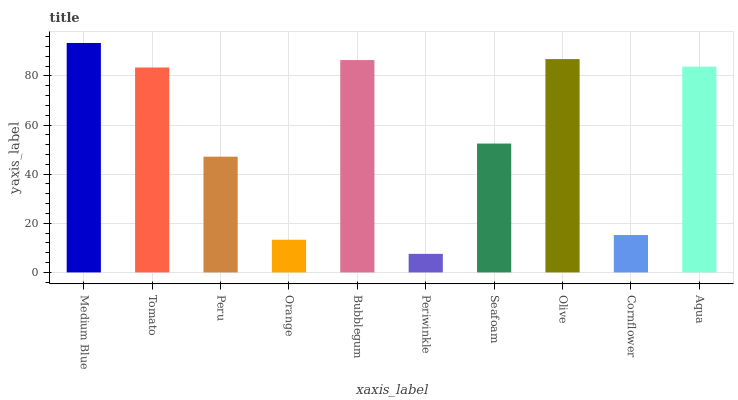Is Periwinkle the minimum?
Answer yes or no. Yes. Is Medium Blue the maximum?
Answer yes or no. Yes. Is Tomato the minimum?
Answer yes or no. No. Is Tomato the maximum?
Answer yes or no. No. Is Medium Blue greater than Tomato?
Answer yes or no. Yes. Is Tomato less than Medium Blue?
Answer yes or no. Yes. Is Tomato greater than Medium Blue?
Answer yes or no. No. Is Medium Blue less than Tomato?
Answer yes or no. No. Is Tomato the high median?
Answer yes or no. Yes. Is Seafoam the low median?
Answer yes or no. Yes. Is Bubblegum the high median?
Answer yes or no. No. Is Bubblegum the low median?
Answer yes or no. No. 